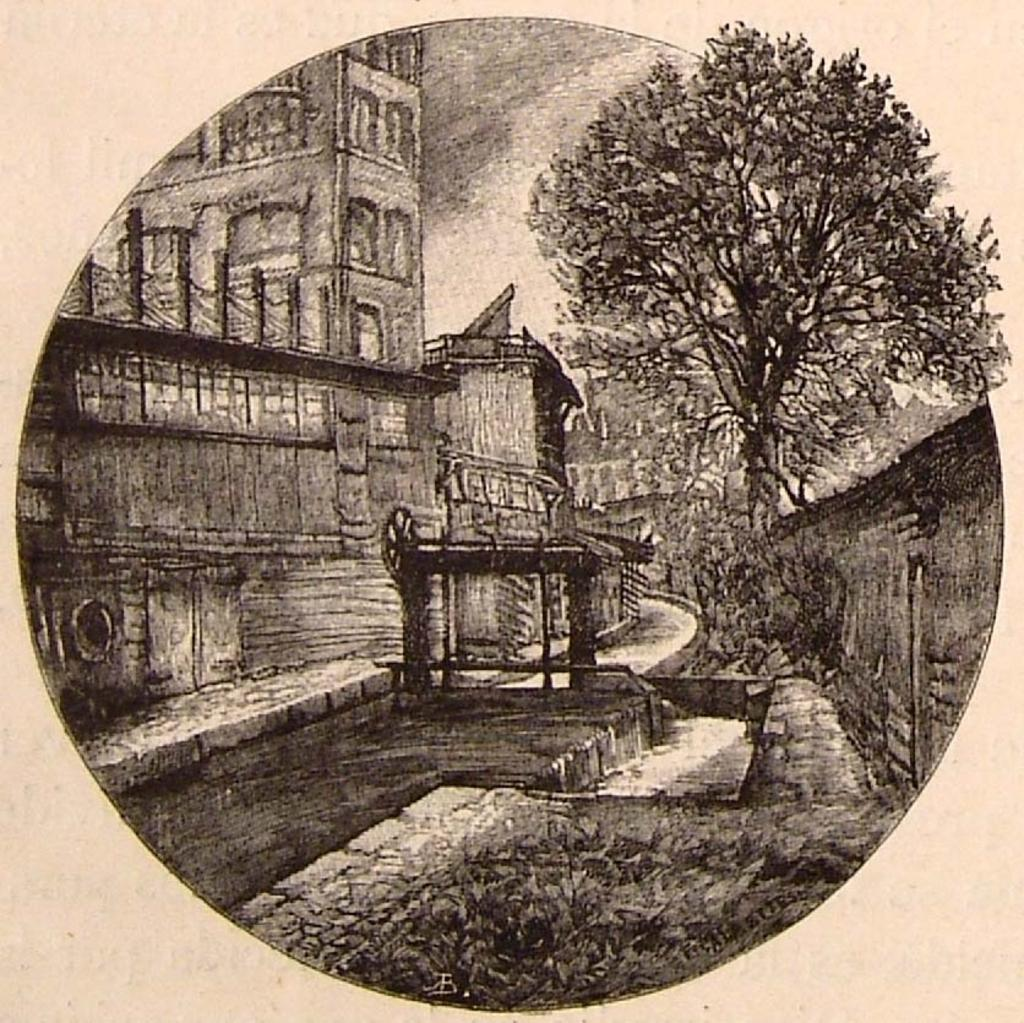What is depicted on the paper in the image? There is art on a paper in the image. What type of leaf is used in the art on the paper? There is no leaf present in the image; it only features art on a paper. What type of polish is used to create the art on the paper? There is no information about the materials or techniques used to create the art on the paper in the image. 